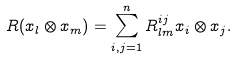Convert formula to latex. <formula><loc_0><loc_0><loc_500><loc_500>R ( x _ { l } \otimes x _ { m } ) = \sum _ { i , j = 1 } ^ { n } R ^ { i j } _ { l m } x _ { i } \otimes x _ { j } .</formula> 